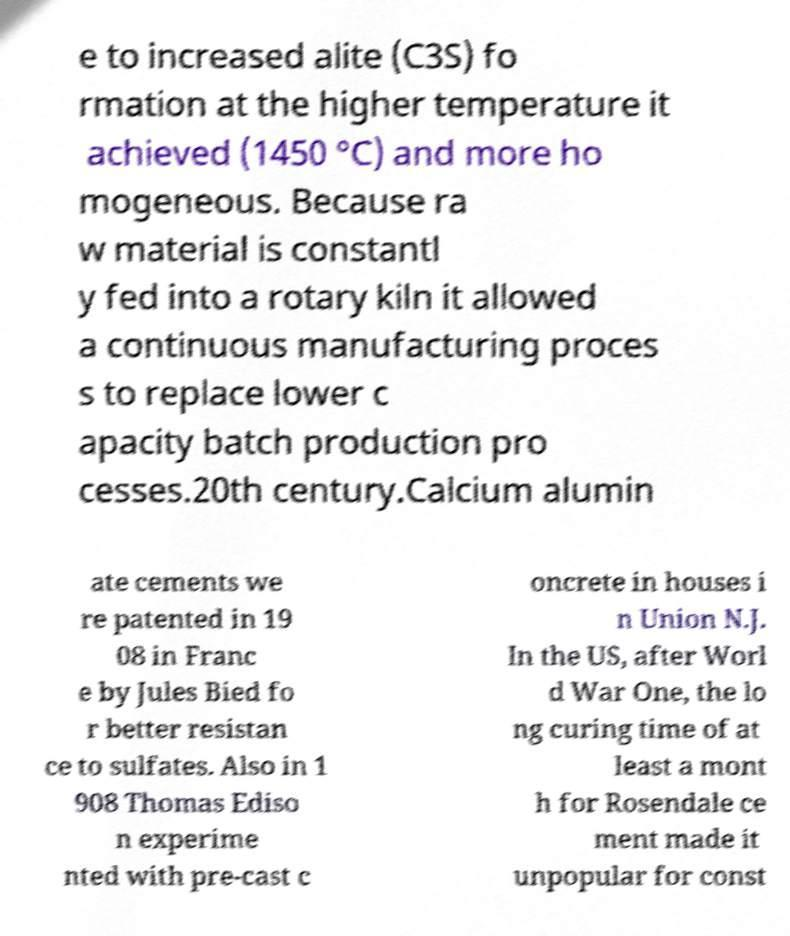There's text embedded in this image that I need extracted. Can you transcribe it verbatim? e to increased alite (C3S) fo rmation at the higher temperature it achieved (1450 °C) and more ho mogeneous. Because ra w material is constantl y fed into a rotary kiln it allowed a continuous manufacturing proces s to replace lower c apacity batch production pro cesses.20th century.Calcium alumin ate cements we re patented in 19 08 in Franc e by Jules Bied fo r better resistan ce to sulfates. Also in 1 908 Thomas Ediso n experime nted with pre-cast c oncrete in houses i n Union N.J. In the US, after Worl d War One, the lo ng curing time of at least a mont h for Rosendale ce ment made it unpopular for const 